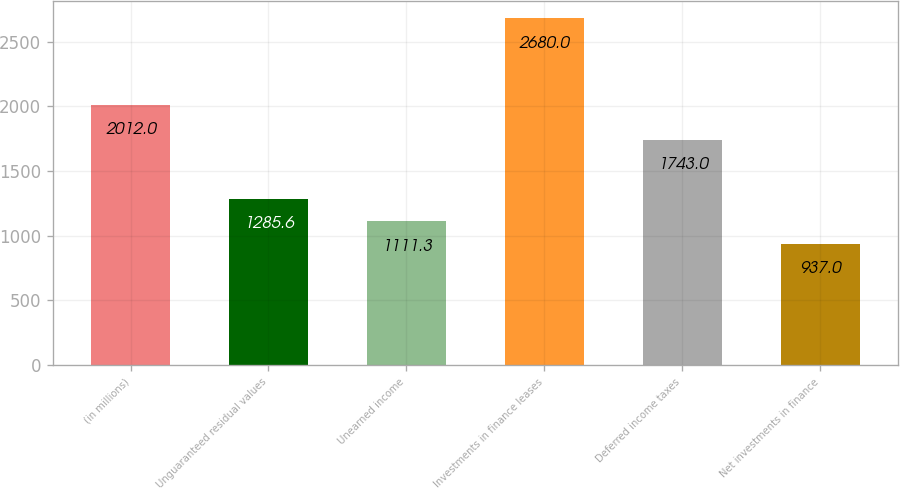Convert chart. <chart><loc_0><loc_0><loc_500><loc_500><bar_chart><fcel>(in millions)<fcel>Unguaranteed residual values<fcel>Unearned income<fcel>Investments in finance leases<fcel>Deferred income taxes<fcel>Net investments in finance<nl><fcel>2012<fcel>1285.6<fcel>1111.3<fcel>2680<fcel>1743<fcel>937<nl></chart> 